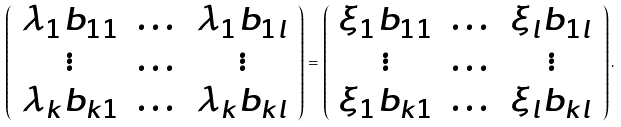<formula> <loc_0><loc_0><loc_500><loc_500>\left ( \begin{array} { c c c } \lambda _ { 1 } b _ { 1 1 } & \dots & \lambda _ { 1 } b _ { 1 l } \\ \vdots & \dots & \vdots \\ \lambda _ { k } b _ { k 1 } & \dots & \lambda _ { k } b _ { k l } \end{array} \right ) = \left ( \begin{array} { c c c } \xi _ { 1 } b _ { 1 1 } & \dots & \xi _ { l } b _ { 1 l } \\ \vdots & \dots & \vdots \\ \xi _ { 1 } b _ { k 1 } & \dots & \xi _ { l } b _ { k l } \end{array} \right ) .</formula> 